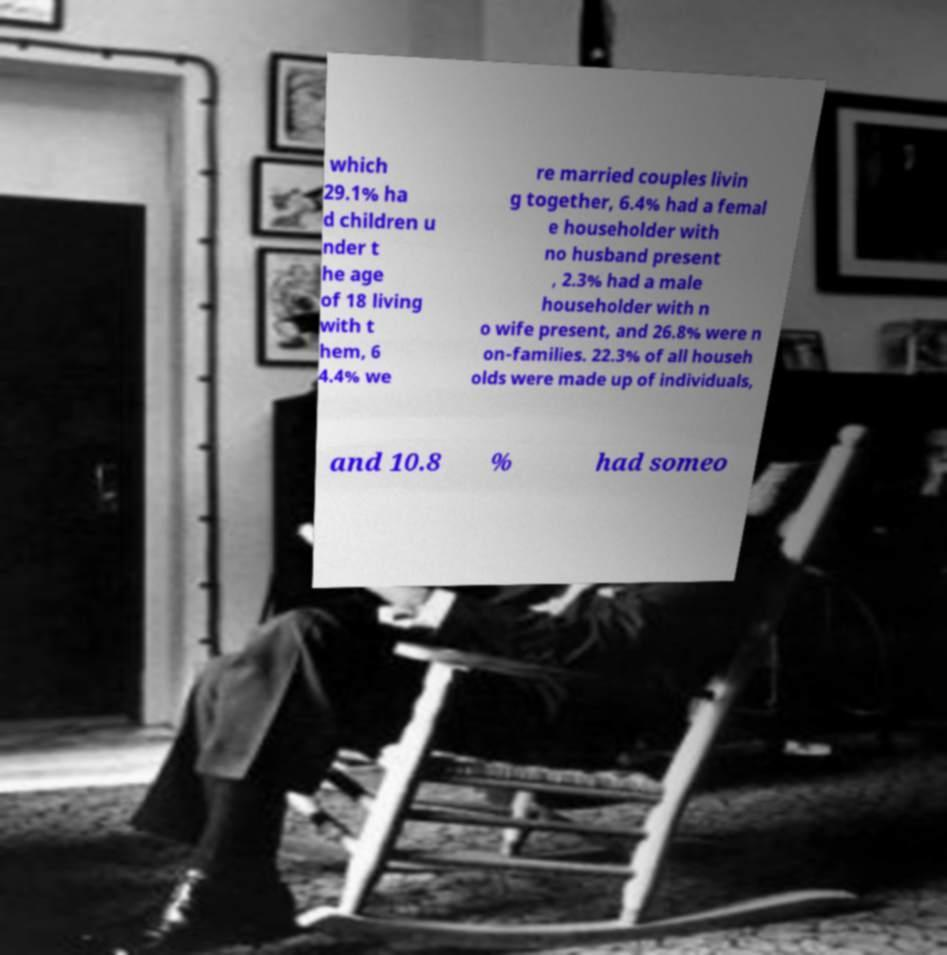Could you assist in decoding the text presented in this image and type it out clearly? which 29.1% ha d children u nder t he age of 18 living with t hem, 6 4.4% we re married couples livin g together, 6.4% had a femal e householder with no husband present , 2.3% had a male householder with n o wife present, and 26.8% were n on-families. 22.3% of all househ olds were made up of individuals, and 10.8 % had someo 